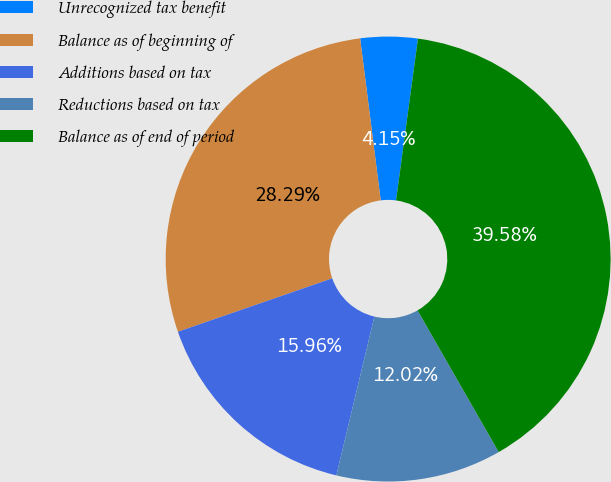<chart> <loc_0><loc_0><loc_500><loc_500><pie_chart><fcel>Unrecognized tax benefit<fcel>Balance as of beginning of<fcel>Additions based on tax<fcel>Reductions based on tax<fcel>Balance as of end of period<nl><fcel>4.15%<fcel>28.29%<fcel>15.96%<fcel>12.02%<fcel>39.58%<nl></chart> 